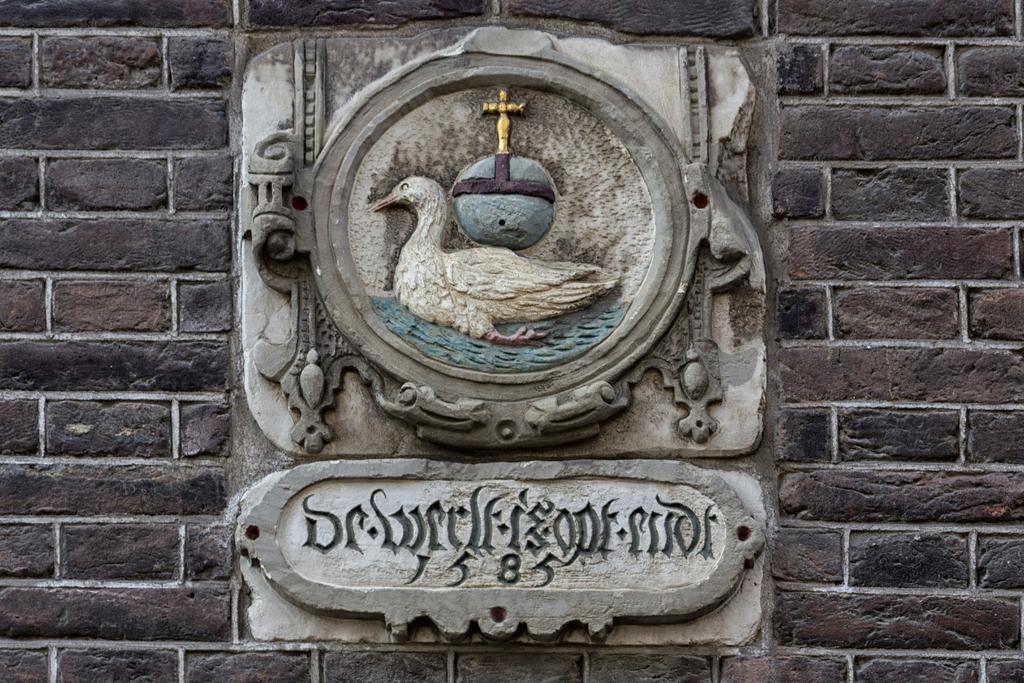How would you summarize this image in a sentence or two? In this image we can see the sculpture on the wall. There is some text on below the sculpture. 